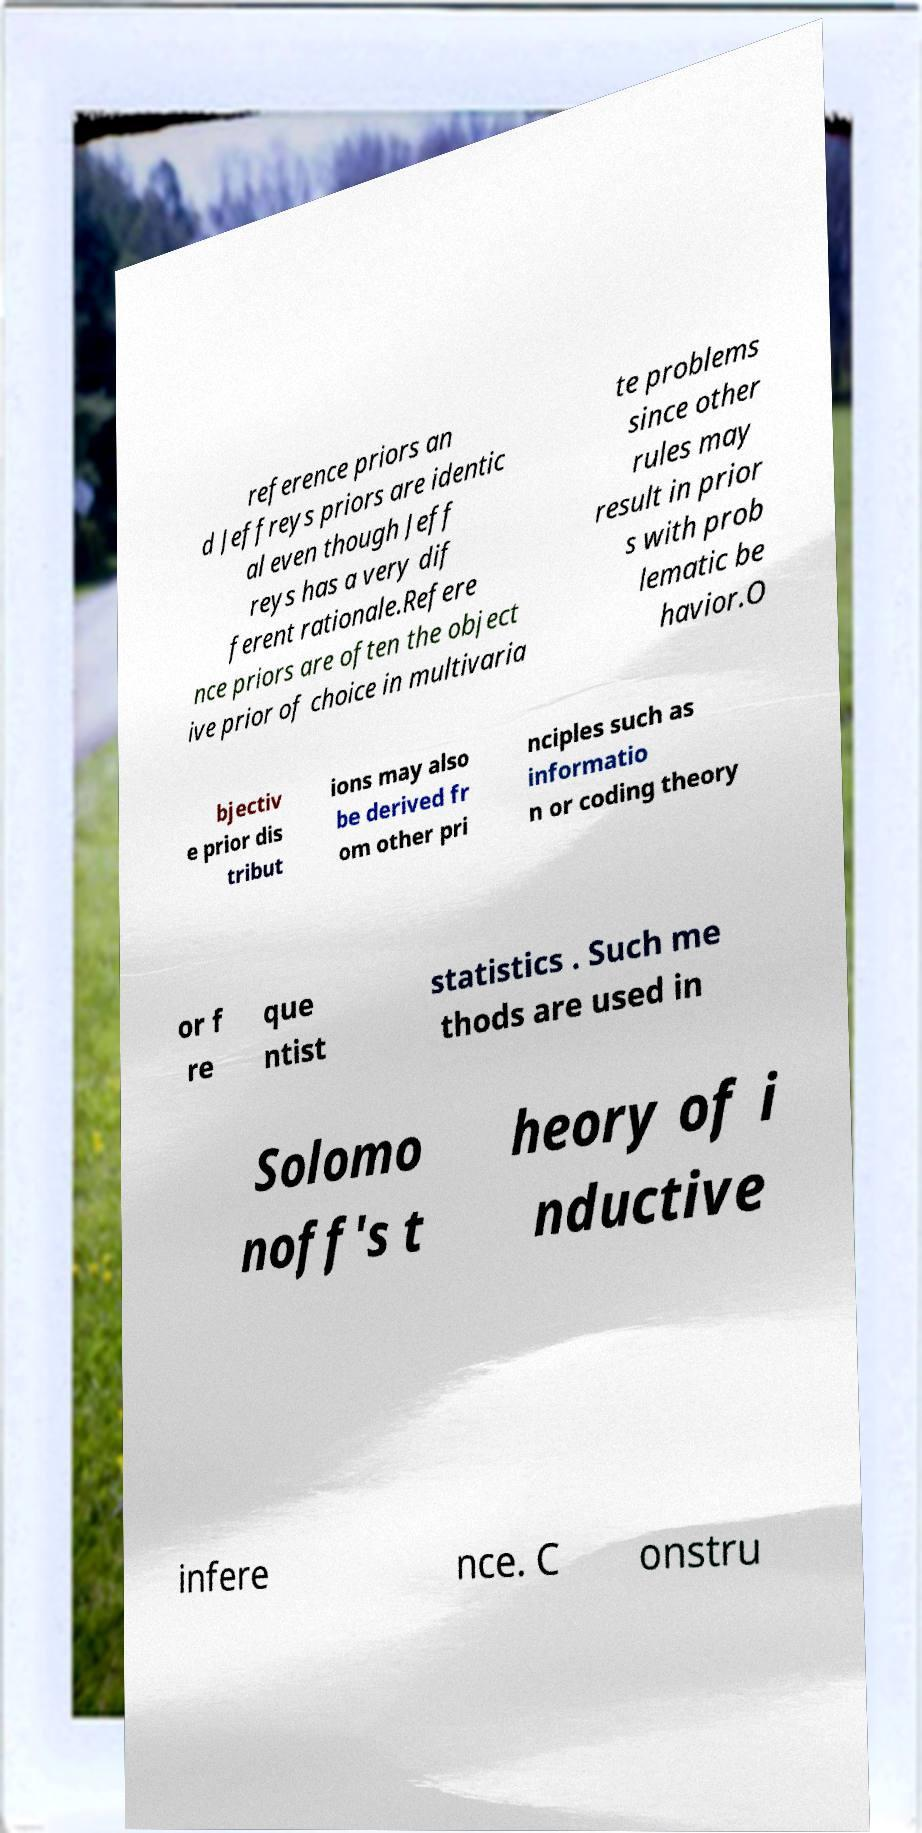Could you assist in decoding the text presented in this image and type it out clearly? reference priors an d Jeffreys priors are identic al even though Jeff reys has a very dif ferent rationale.Refere nce priors are often the object ive prior of choice in multivaria te problems since other rules may result in prior s with prob lematic be havior.O bjectiv e prior dis tribut ions may also be derived fr om other pri nciples such as informatio n or coding theory or f re que ntist statistics . Such me thods are used in Solomo noff's t heory of i nductive infere nce. C onstru 